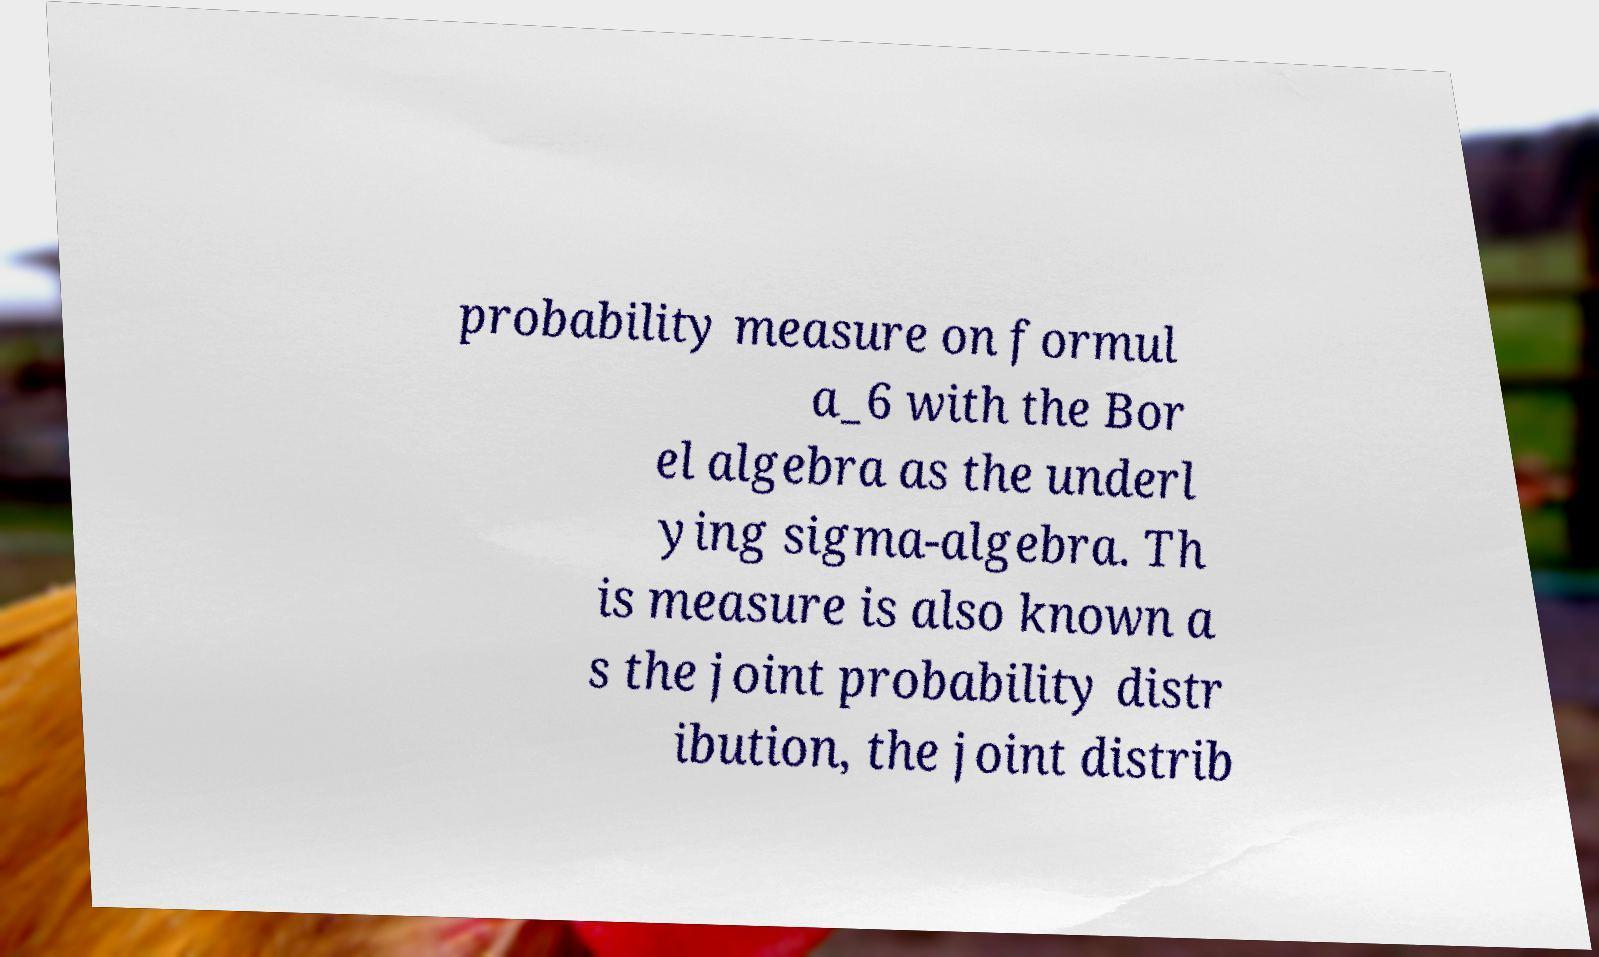For documentation purposes, I need the text within this image transcribed. Could you provide that? probability measure on formul a_6 with the Bor el algebra as the underl ying sigma-algebra. Th is measure is also known a s the joint probability distr ibution, the joint distrib 